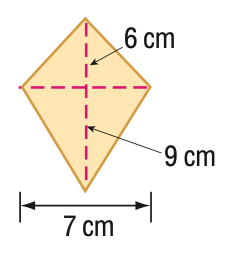Answer the mathemtical geometry problem and directly provide the correct option letter.
Question: Find the area of the kite.
Choices: A: 42 B: 52.5 C: 54 D: 63 B 